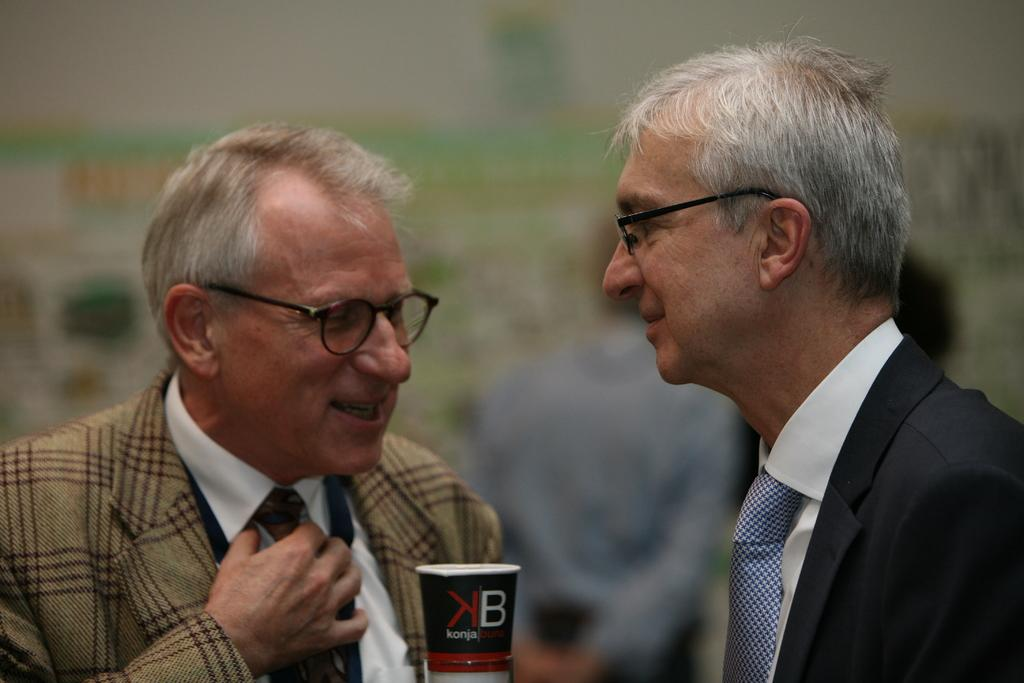How many people are in the image? There are two persons in the image. Where is the person on the left side located? The person on the left side is standing. What is the person on the left side holding? The person on the left side is holding a book. What is the person on the right side wearing? The person on the right side is wearing a jacket. What type of education can be seen in the image? There is no specific education depicted in the image; it only shows two people, one holding a book and the other wearing a jacket. 